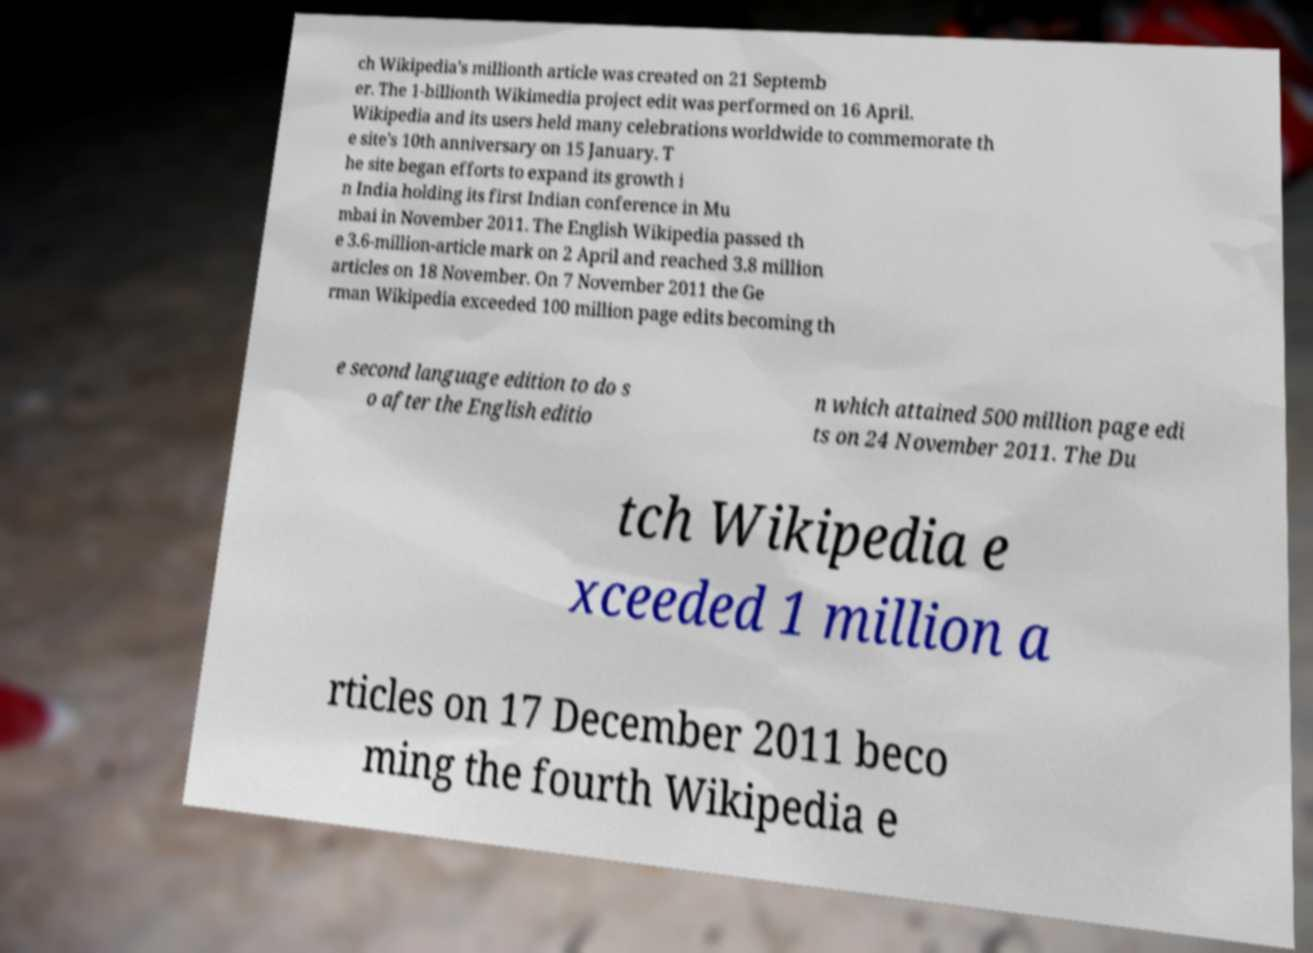Can you read and provide the text displayed in the image?This photo seems to have some interesting text. Can you extract and type it out for me? ch Wikipedia's millionth article was created on 21 Septemb er. The 1-billionth Wikimedia project edit was performed on 16 April. Wikipedia and its users held many celebrations worldwide to commemorate th e site's 10th anniversary on 15 January. T he site began efforts to expand its growth i n India holding its first Indian conference in Mu mbai in November 2011. The English Wikipedia passed th e 3.6-million-article mark on 2 April and reached 3.8 million articles on 18 November. On 7 November 2011 the Ge rman Wikipedia exceeded 100 million page edits becoming th e second language edition to do s o after the English editio n which attained 500 million page edi ts on 24 November 2011. The Du tch Wikipedia e xceeded 1 million a rticles on 17 December 2011 beco ming the fourth Wikipedia e 